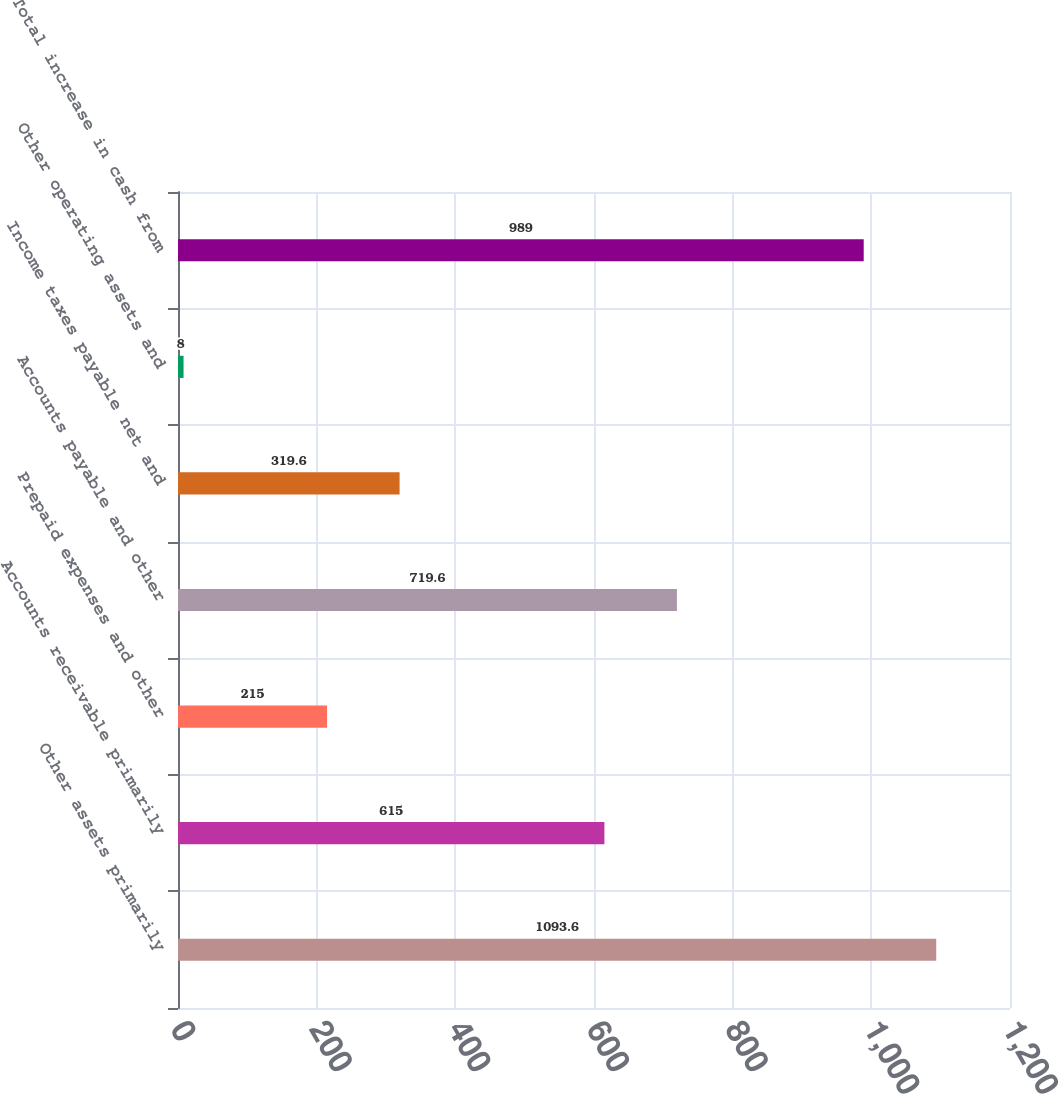<chart> <loc_0><loc_0><loc_500><loc_500><bar_chart><fcel>Other assets primarily<fcel>Accounts receivable primarily<fcel>Prepaid expenses and other<fcel>Accounts payable and other<fcel>Income taxes payable net and<fcel>Other operating assets and<fcel>Total increase in cash from<nl><fcel>1093.6<fcel>615<fcel>215<fcel>719.6<fcel>319.6<fcel>8<fcel>989<nl></chart> 